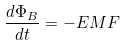<formula> <loc_0><loc_0><loc_500><loc_500>\frac { d \Phi _ { B } } { d t } = - E M F</formula> 